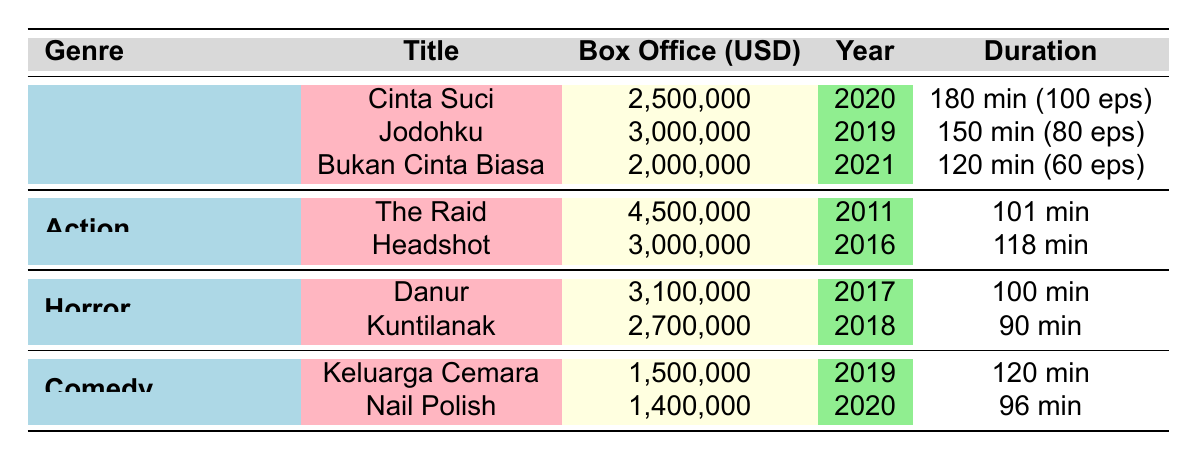What is the box office revenue of "Jodohku"? The revenue for "Jodohku" is listed in the table, which shows it clearly. It states that the box office revenue for this film is 3,000,000 USD.
Answer: 3,000,000 USD Which Indonesian drama has the highest box office revenue? From the table, we see the revenues of the Indonesian dramas: "Cinta Suci" (2,500,000), "Jodohku" (3,000,000), and "Bukan Cinta Biasa" (2,000,000). "Jodohku" has the highest revenue among them.
Answer: Jodohku What is the average box office revenue of the action genre films? There are two action films: "The Raid" with 4,500,000 and "Headshot" with 3,000,000. The average is calculated by summing them (4,500,000 + 3,000,000 = 7,500,000) and dividing by 2, which is 3,750,000.
Answer: 3,750,000 USD Did any comedy film reach a box office revenue of more than 2 million USD? The comedy films listed are "Keluarga Cemara" (1,500,000) and "Nail Polish" (1,400,000). Neither of them exceeds 2 million USD, making this statement false.
Answer: No Which genre has a higher total box office revenue: Indonesian Drama or Horror? The total revenue for Indonesian dramas is 2,500,000 + 3,000,000 + 2,000,000 = 7,500,000, while for horror, it totals 3,100,000 + 2,700,000 = 5,800,000. Therefore, Indonesian Drama has a higher total revenue.
Answer: Indonesian Drama 